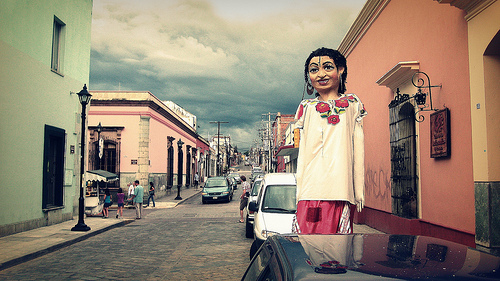<image>
Is the man next to the street light? Yes. The man is positioned adjacent to the street light, located nearby in the same general area. Is there a pole behind the car? Yes. From this viewpoint, the pole is positioned behind the car, with the car partially or fully occluding the pole. 